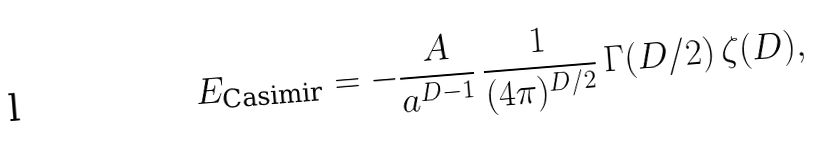<formula> <loc_0><loc_0><loc_500><loc_500>E _ { \text {Casimir} } = - \frac { A } { a ^ { D - 1 } } \, \frac { 1 } { ( 4 \pi ) ^ { D / 2 } } \, \Gamma ( D / 2 ) \, \zeta ( D ) ,</formula> 